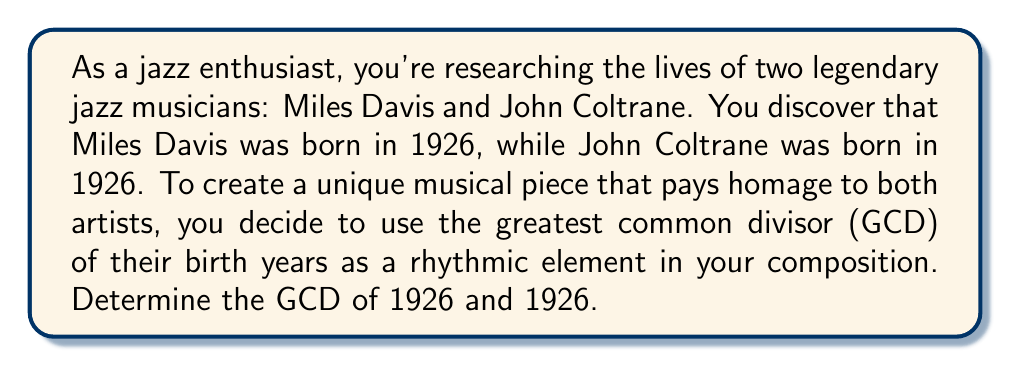Give your solution to this math problem. To find the greatest common divisor (GCD) of 1926 and 1926, we can use the Euclidean algorithm. However, in this case, both numbers are the same, which simplifies our process.

Step 1: Identify the numbers
$a = 1926$
$b = 1926$

Step 2: Since $a = b$, the GCD is simply the number itself.

In number theory, it's a fundamental property that for any positive integer $n$:

$GCD(n, n) = n$

This is because any number is divisible by itself, and there can't be a larger common divisor than the number itself when both inputs are equal.

Therefore, $GCD(1926, 1926) = 1926$

This result means that 1926 is the largest positive integer that divides both 1926 and 1926 without leaving a remainder.

Musically, you could interpret this number in various ways, such as:
- Using 19 beats in a measure and 26 measures in a section
- Creating a rhythmic pattern based on the digits 1, 9, 2, and 6
- Using 1926 as a tempo marking (although this would be extremely fast!)
Answer: $GCD(1926, 1926) = 1926$ 